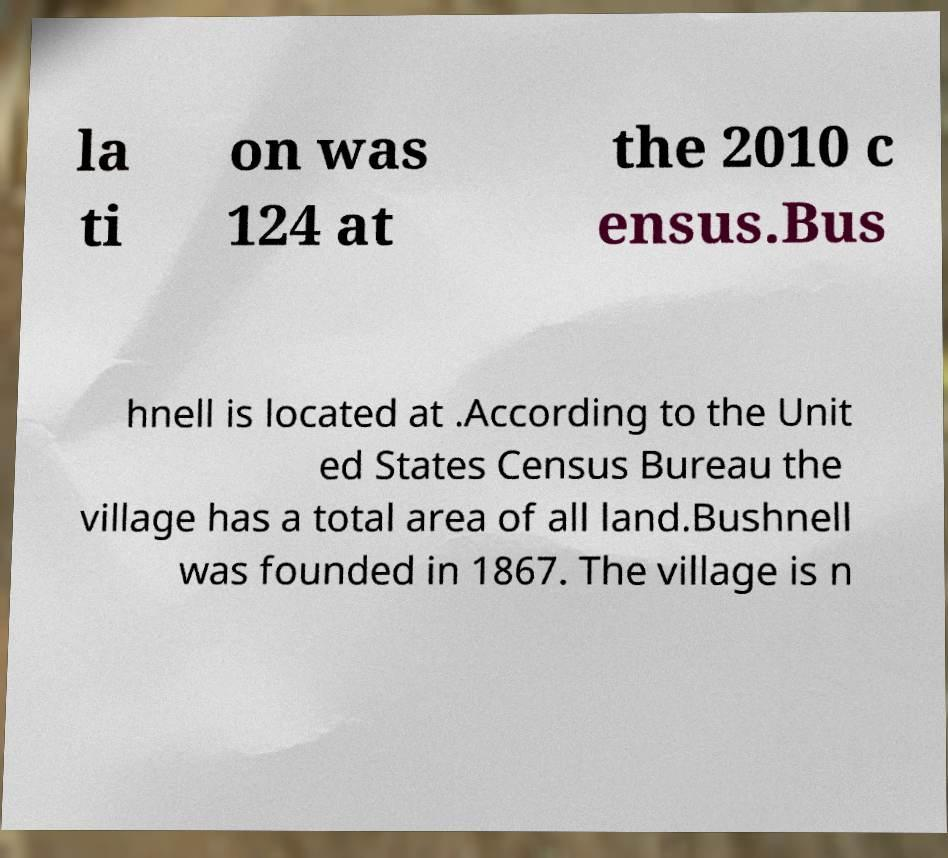For documentation purposes, I need the text within this image transcribed. Could you provide that? la ti on was 124 at the 2010 c ensus.Bus hnell is located at .According to the Unit ed States Census Bureau the village has a total area of all land.Bushnell was founded in 1867. The village is n 